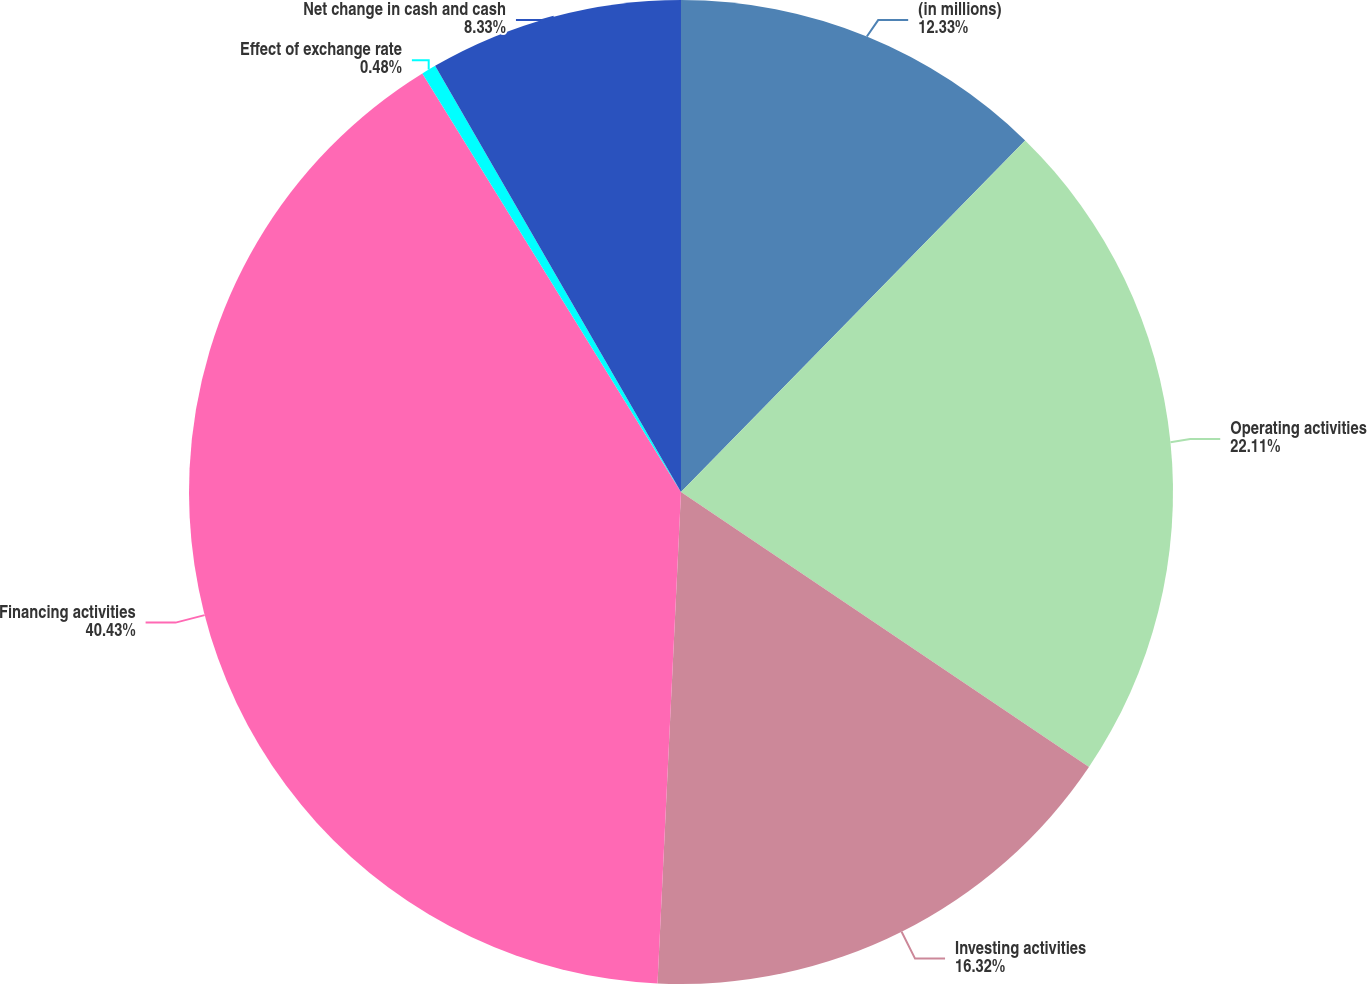Convert chart to OTSL. <chart><loc_0><loc_0><loc_500><loc_500><pie_chart><fcel>(in millions)<fcel>Operating activities<fcel>Investing activities<fcel>Financing activities<fcel>Effect of exchange rate<fcel>Net change in cash and cash<nl><fcel>12.33%<fcel>22.11%<fcel>16.32%<fcel>40.43%<fcel>0.48%<fcel>8.33%<nl></chart> 